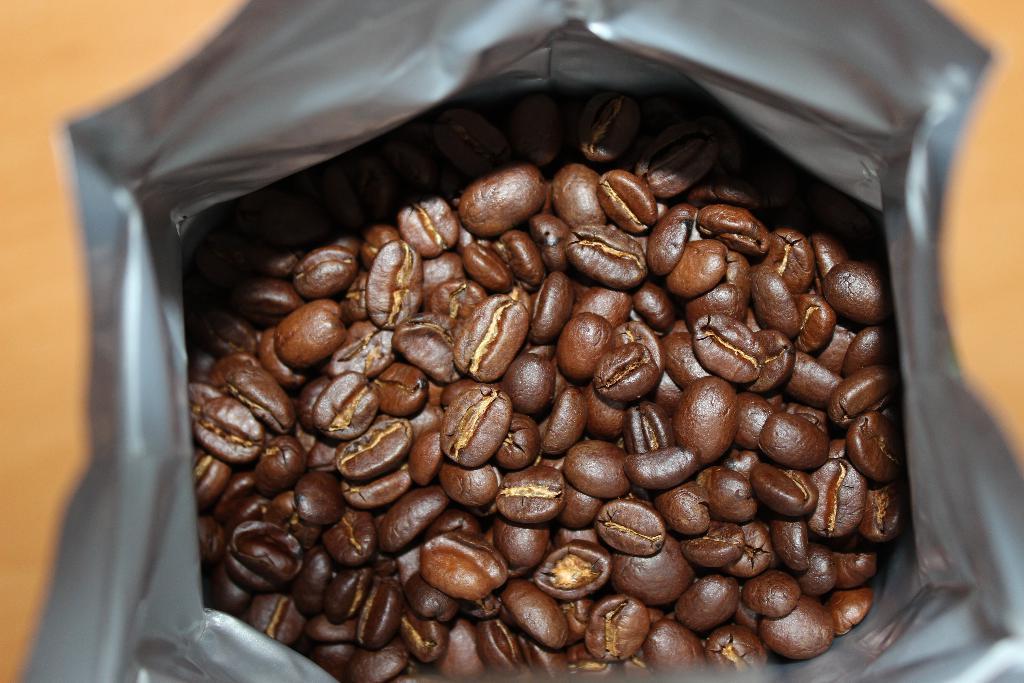Please provide a concise description of this image. In this image I see the beans which are of brown in color and they're in the grey color cover here and it is blurred in the background. 